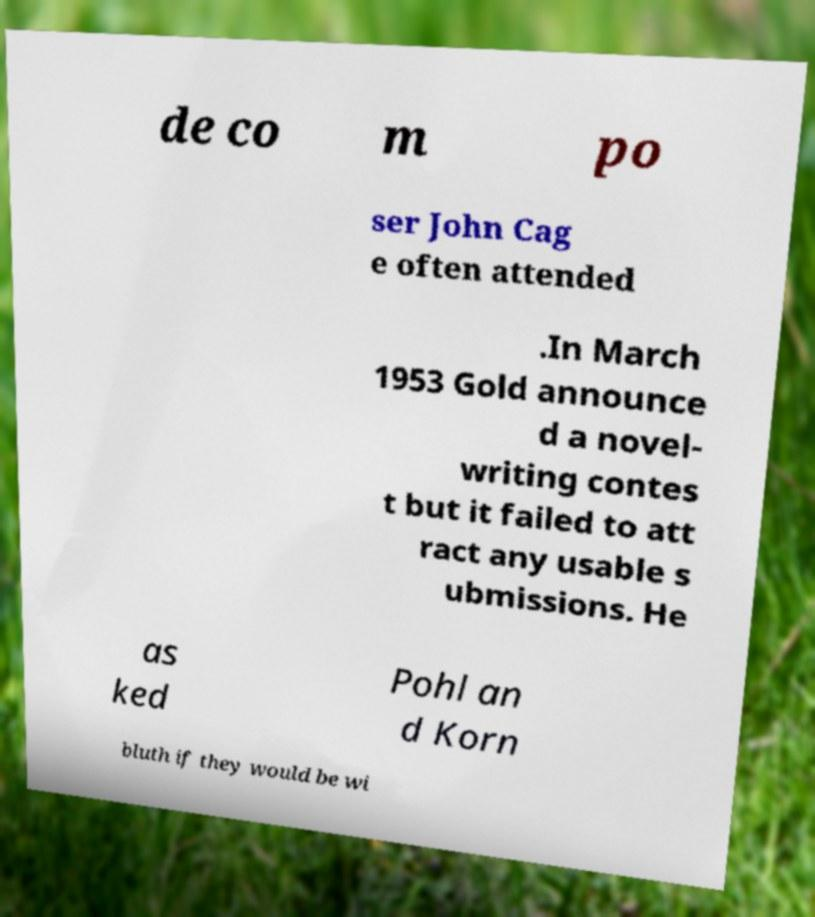For documentation purposes, I need the text within this image transcribed. Could you provide that? de co m po ser John Cag e often attended .In March 1953 Gold announce d a novel- writing contes t but it failed to att ract any usable s ubmissions. He as ked Pohl an d Korn bluth if they would be wi 